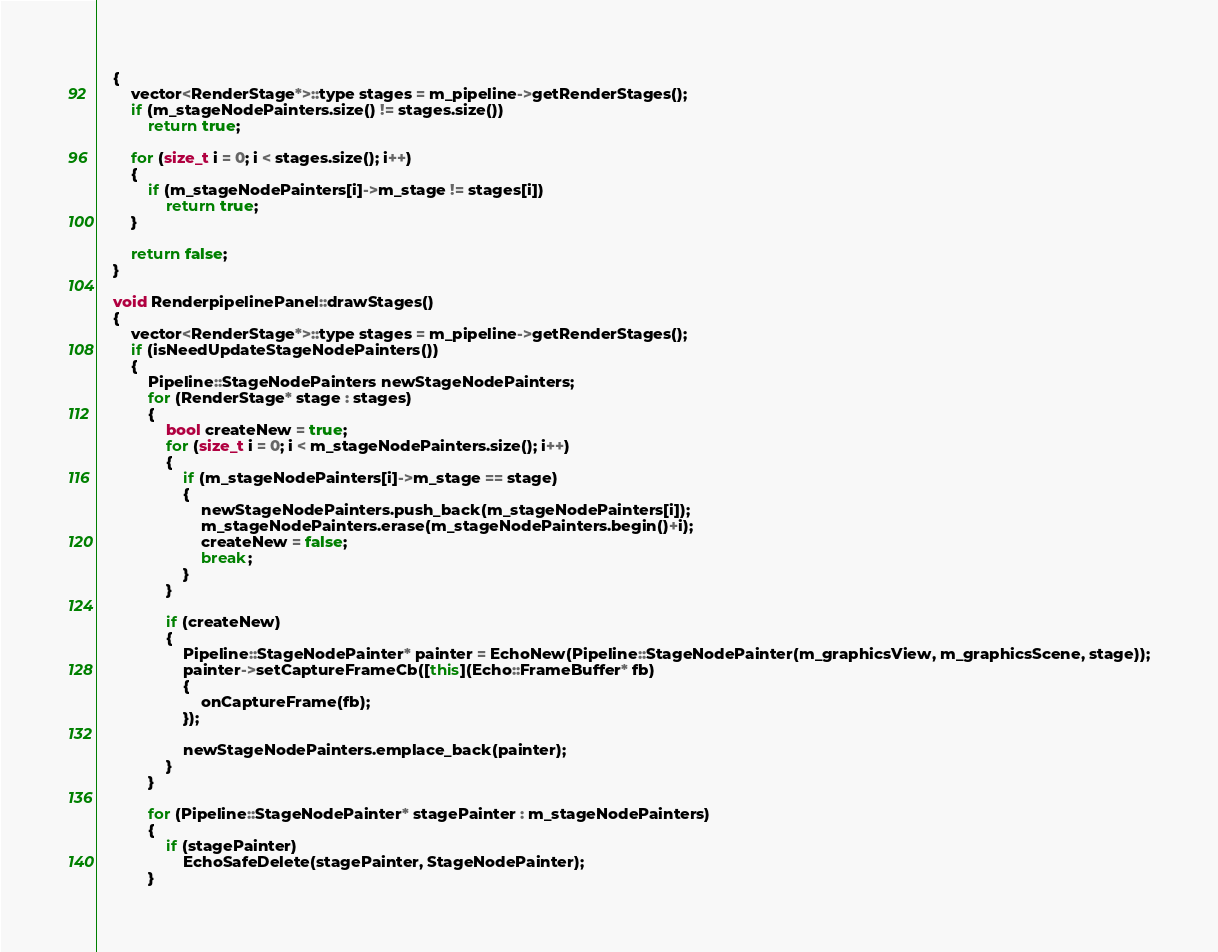Convert code to text. <code><loc_0><loc_0><loc_500><loc_500><_C++_>	{
		vector<RenderStage*>::type stages = m_pipeline->getRenderStages();
		if (m_stageNodePainters.size() != stages.size())
			return true;

		for (size_t i = 0; i < stages.size(); i++)
		{
			if (m_stageNodePainters[i]->m_stage != stages[i])
				return true;
		}

		return false;
	}

	void RenderpipelinePanel::drawStages()
	{
		vector<RenderStage*>::type stages = m_pipeline->getRenderStages();
		if (isNeedUpdateStageNodePainters())
		{
			Pipeline::StageNodePainters newStageNodePainters;
			for (RenderStage* stage : stages)
			{
				bool createNew = true;
				for (size_t i = 0; i < m_stageNodePainters.size(); i++)
				{
					if (m_stageNodePainters[i]->m_stage == stage)
					{
						newStageNodePainters.push_back(m_stageNodePainters[i]);
						m_stageNodePainters.erase(m_stageNodePainters.begin()+i);
						createNew = false;
						break;
					}
				}

				if (createNew)
				{
					Pipeline::StageNodePainter* painter = EchoNew(Pipeline::StageNodePainter(m_graphicsView, m_graphicsScene, stage));
					painter->setCaptureFrameCb([this](Echo::FrameBuffer* fb) 
					{
						onCaptureFrame(fb);
					});

					newStageNodePainters.emplace_back(painter);
				}
			}

			for (Pipeline::StageNodePainter* stagePainter : m_stageNodePainters)
			{
				if (stagePainter)
					EchoSafeDelete(stagePainter, StageNodePainter);
			}
</code> 